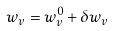<formula> <loc_0><loc_0><loc_500><loc_500>w _ { v } = w ^ { 0 } _ { v } + \delta w _ { v }</formula> 